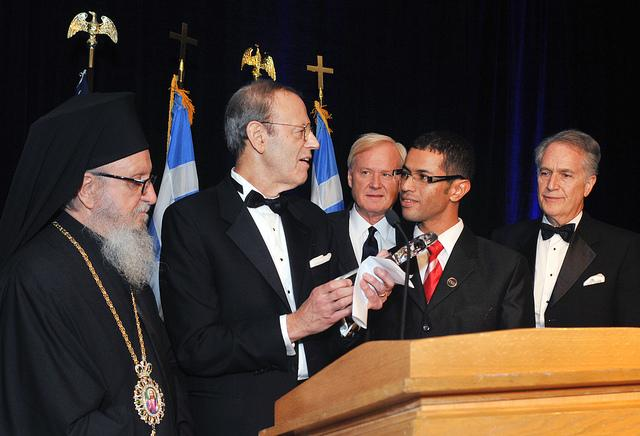The man on the left is probably a member of what type of group?

Choices:
A) politician
B) teacher
C) farmer
D) clergy clergy 